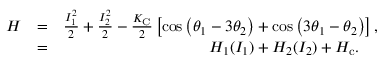Convert formula to latex. <formula><loc_0><loc_0><loc_500><loc_500>\begin{array} { r l r } { H } & { = } & { \frac { I _ { 1 } ^ { 2 } } { 2 } + \frac { I _ { 2 } ^ { 2 } } { 2 } - \frac { K _ { C } } { 2 } \left [ \cos \left ( \theta _ { 1 } - 3 \theta _ { 2 } \right ) + \cos \left ( 3 \theta _ { 1 } - \theta _ { 2 } \right ) \right ] , } \\ & { = } & { H _ { 1 } ( I _ { 1 } ) + H _ { 2 } ( I _ { 2 } ) + H _ { c } . \quad \, } \end{array}</formula> 